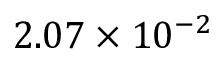Convert formula to latex. <formula><loc_0><loc_0><loc_500><loc_500>2 . 0 7 \times 1 0 ^ { - 2 }</formula> 